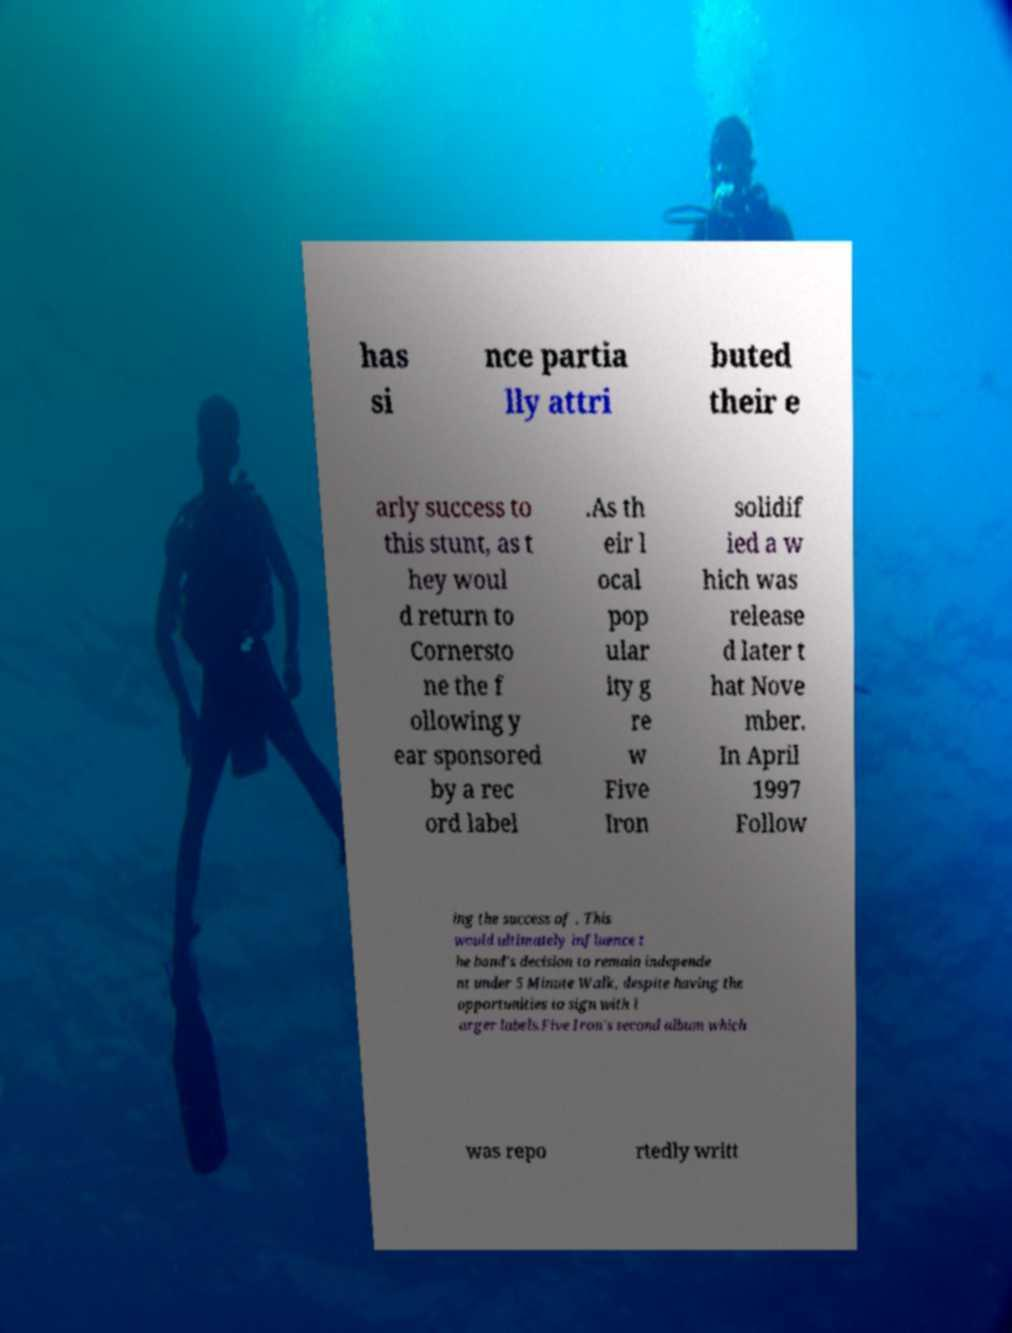Please identify and transcribe the text found in this image. has si nce partia lly attri buted their e arly success to this stunt, as t hey woul d return to Cornersto ne the f ollowing y ear sponsored by a rec ord label .As th eir l ocal pop ular ity g re w Five Iron solidif ied a w hich was release d later t hat Nove mber. In April 1997 Follow ing the success of . This would ultimately influence t he band's decision to remain independe nt under 5 Minute Walk, despite having the opportunities to sign with l arger labels.Five Iron's second album which was repo rtedly writt 